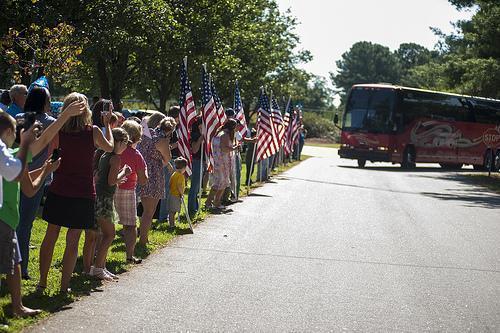How many people wears yellow t-shirts?
Give a very brief answer. 1. 